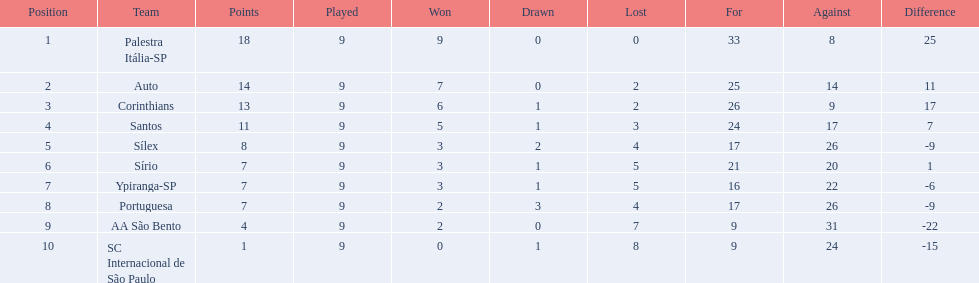How many units competed in football in brazil during 1926? Palestra Itália-SP, Auto, Corinthians, Santos, Sílex, Sírio, Ypiranga-SP, Portuguesa, AA São Bento, SC Internacional de São Paulo. What was the largest number of games prevailed in the 1926 season? 9. Which team occupied the prime spot with 9 victories for the 1926 season? Palestra Itália-SP. 